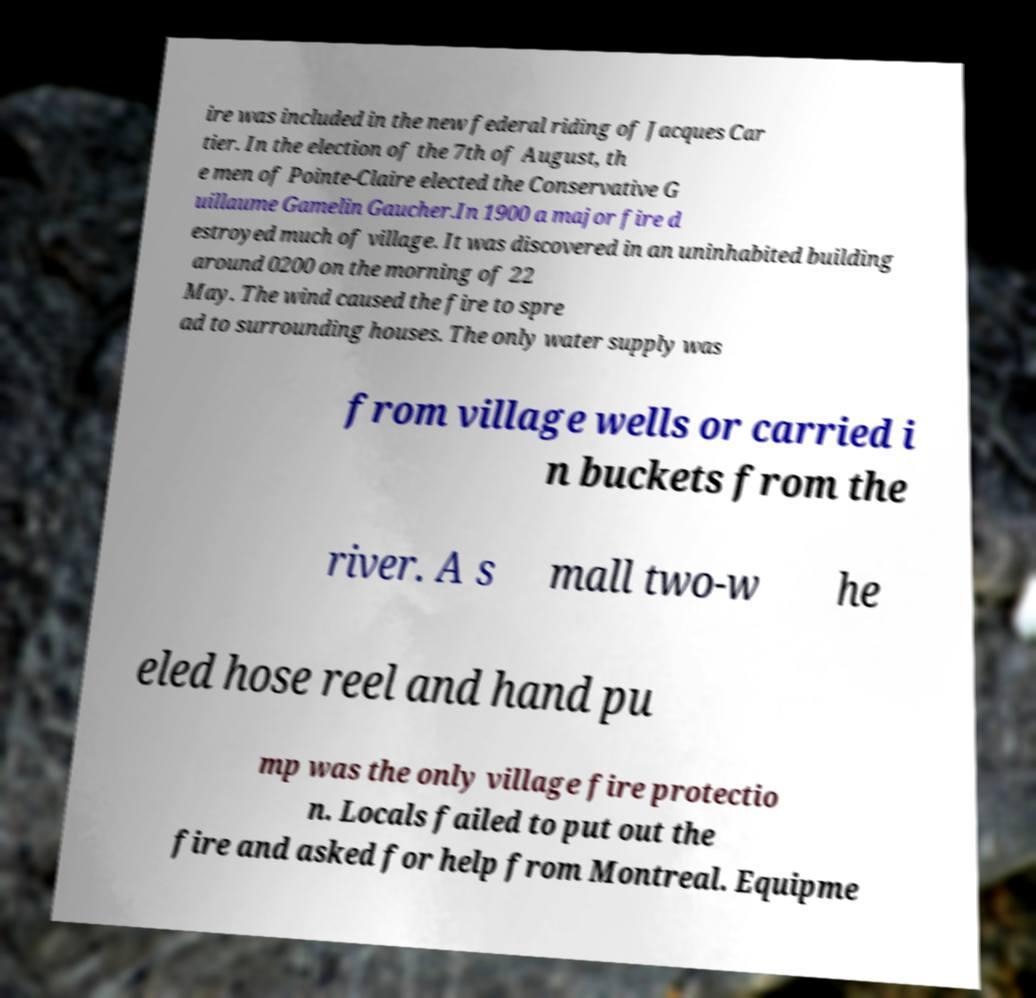For documentation purposes, I need the text within this image transcribed. Could you provide that? ire was included in the new federal riding of Jacques Car tier. In the election of the 7th of August, th e men of Pointe-Claire elected the Conservative G uillaume Gamelin Gaucher.In 1900 a major fire d estroyed much of village. It was discovered in an uninhabited building around 0200 on the morning of 22 May. The wind caused the fire to spre ad to surrounding houses. The only water supply was from village wells or carried i n buckets from the river. A s mall two-w he eled hose reel and hand pu mp was the only village fire protectio n. Locals failed to put out the fire and asked for help from Montreal. Equipme 